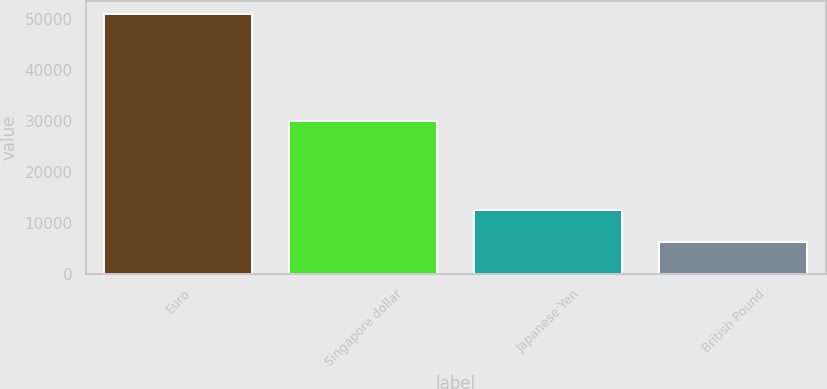<chart> <loc_0><loc_0><loc_500><loc_500><bar_chart><fcel>Euro<fcel>Singapore dollar<fcel>Japanese Yen<fcel>British Pound<nl><fcel>51072<fcel>30123<fcel>12563<fcel>6408<nl></chart> 